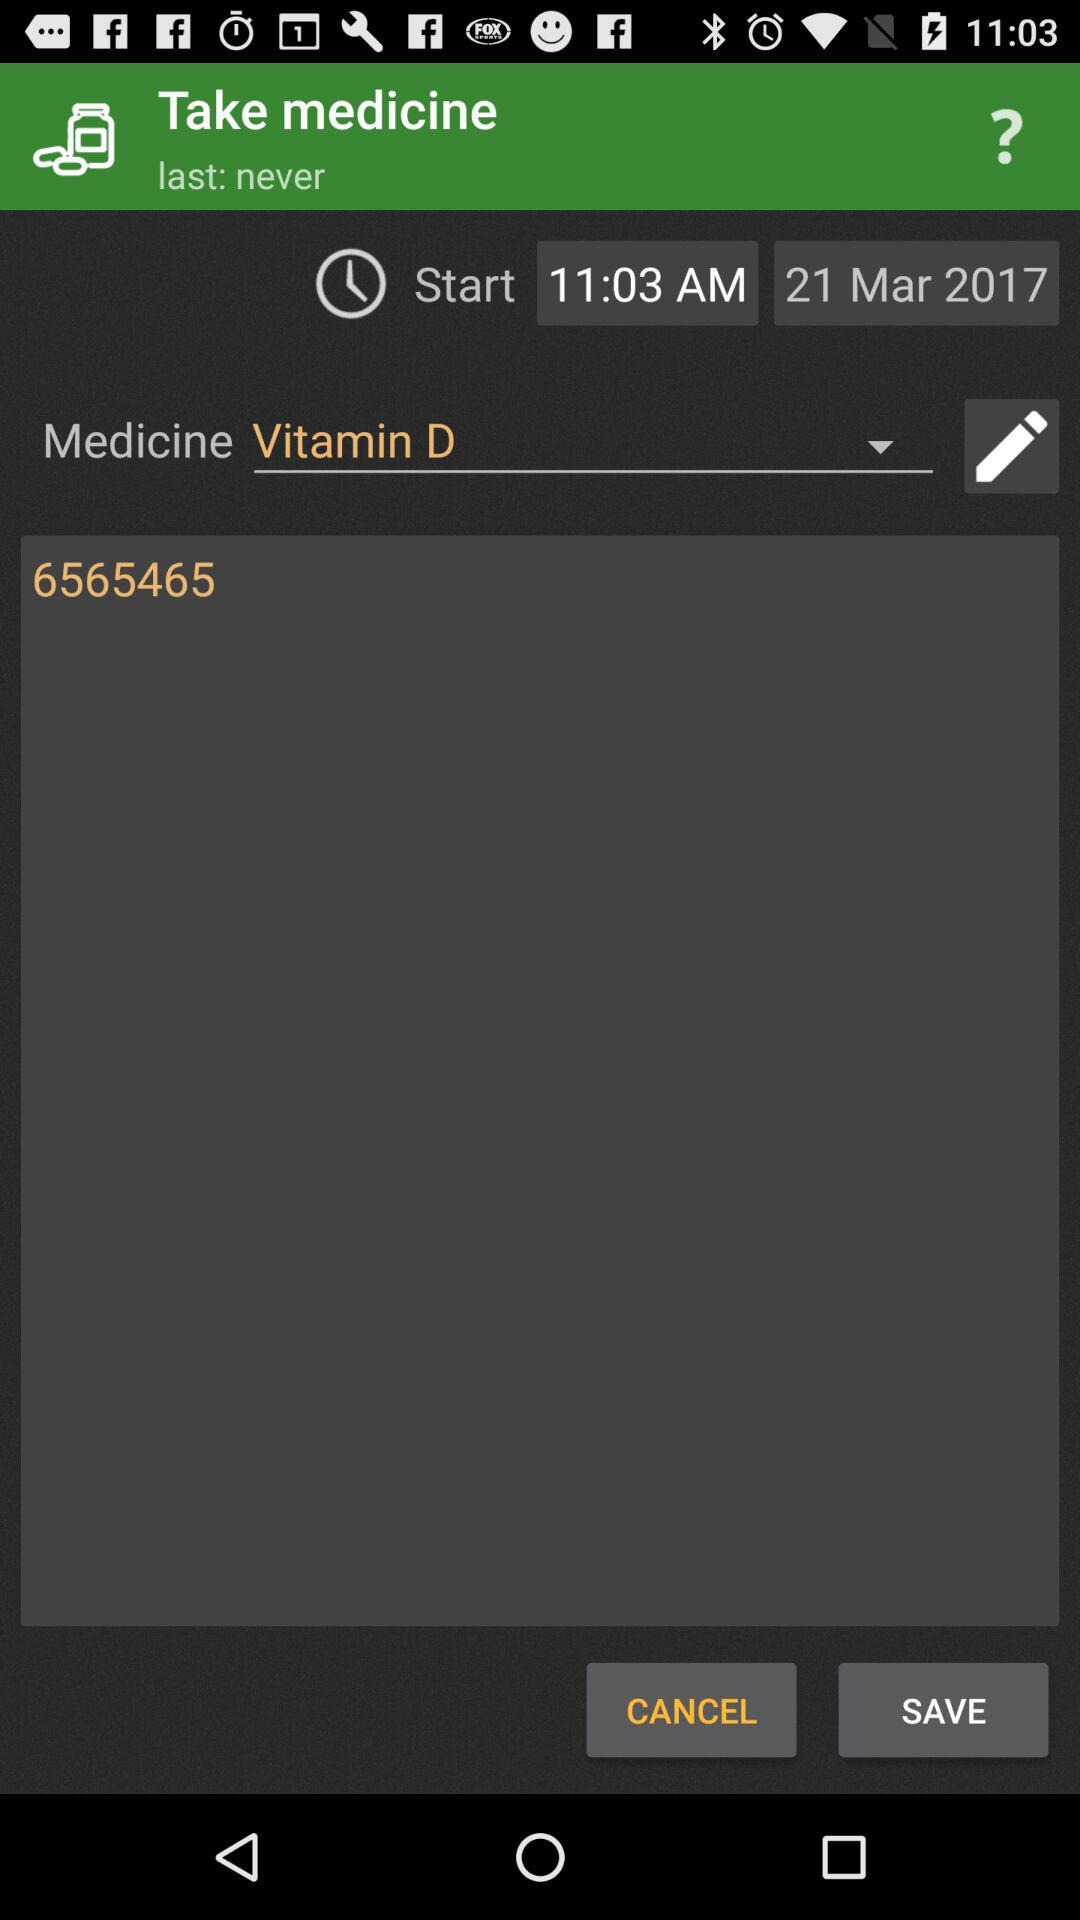What is the start time for taking the medicine? The start time is 11:03 a.m. 